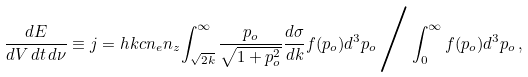<formula> <loc_0><loc_0><loc_500><loc_500>\frac { d E } { d V \, d t \, d \nu } \equiv j = h k c n _ { e } n _ { z } { \int ^ { \infty } _ { \sqrt { 2 k } } \frac { p _ { o } } { \sqrt { 1 + p _ { o } ^ { 2 } } } \frac { d \sigma } { d k } f ( p _ { o } ) d ^ { 3 } p _ { o } } \, \Big . \Big / \, { \int ^ { \infty } _ { 0 } f ( p _ { o } ) d ^ { 3 } p _ { o } } \, ,</formula> 